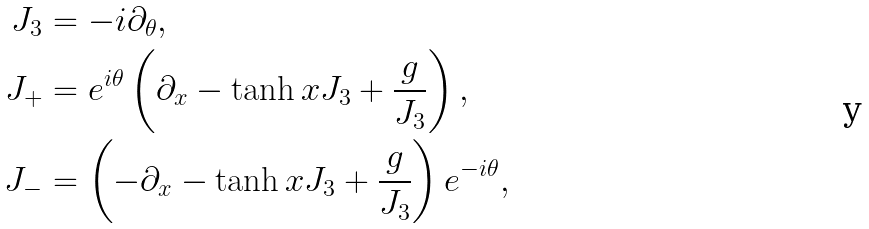Convert formula to latex. <formula><loc_0><loc_0><loc_500><loc_500>J _ { 3 } & = - i \partial _ { \theta } , \\ J _ { + } & = e ^ { i \theta } \left ( \partial _ { x } - \tanh x J _ { 3 } + \frac { g } { J _ { 3 } } \right ) , \\ J _ { - } & = \left ( - \partial _ { x } - \tanh x J _ { 3 } + \frac { g } { J _ { 3 } } \right ) e ^ { - i \theta } ,</formula> 